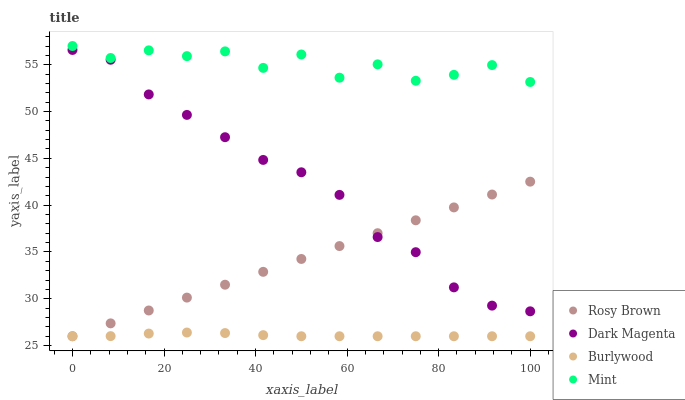Does Burlywood have the minimum area under the curve?
Answer yes or no. Yes. Does Mint have the maximum area under the curve?
Answer yes or no. Yes. Does Rosy Brown have the minimum area under the curve?
Answer yes or no. No. Does Rosy Brown have the maximum area under the curve?
Answer yes or no. No. Is Rosy Brown the smoothest?
Answer yes or no. Yes. Is Mint the roughest?
Answer yes or no. Yes. Is Mint the smoothest?
Answer yes or no. No. Is Rosy Brown the roughest?
Answer yes or no. No. Does Burlywood have the lowest value?
Answer yes or no. Yes. Does Mint have the lowest value?
Answer yes or no. No. Does Mint have the highest value?
Answer yes or no. Yes. Does Rosy Brown have the highest value?
Answer yes or no. No. Is Dark Magenta less than Mint?
Answer yes or no. Yes. Is Mint greater than Burlywood?
Answer yes or no. Yes. Does Burlywood intersect Rosy Brown?
Answer yes or no. Yes. Is Burlywood less than Rosy Brown?
Answer yes or no. No. Is Burlywood greater than Rosy Brown?
Answer yes or no. No. Does Dark Magenta intersect Mint?
Answer yes or no. No. 